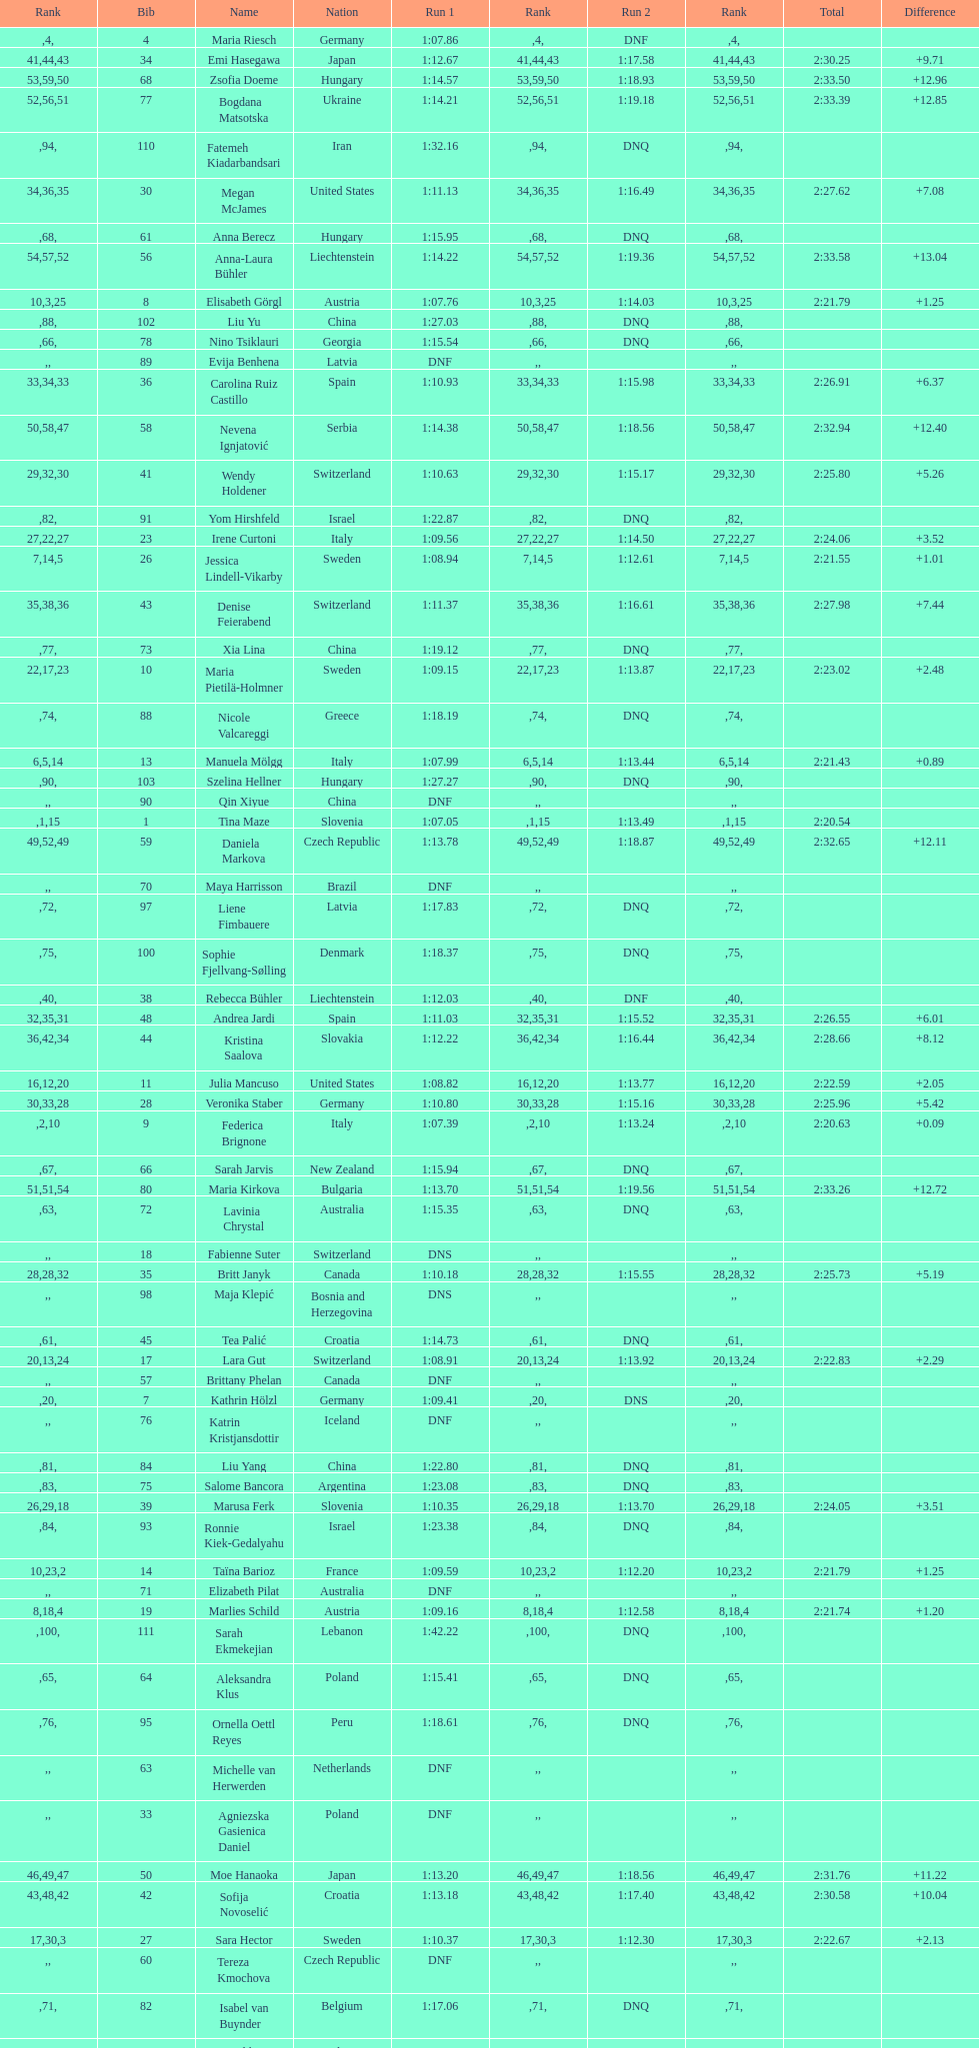What was the number of swedes in the top fifteen? 2. 